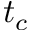Convert formula to latex. <formula><loc_0><loc_0><loc_500><loc_500>t _ { c }</formula> 